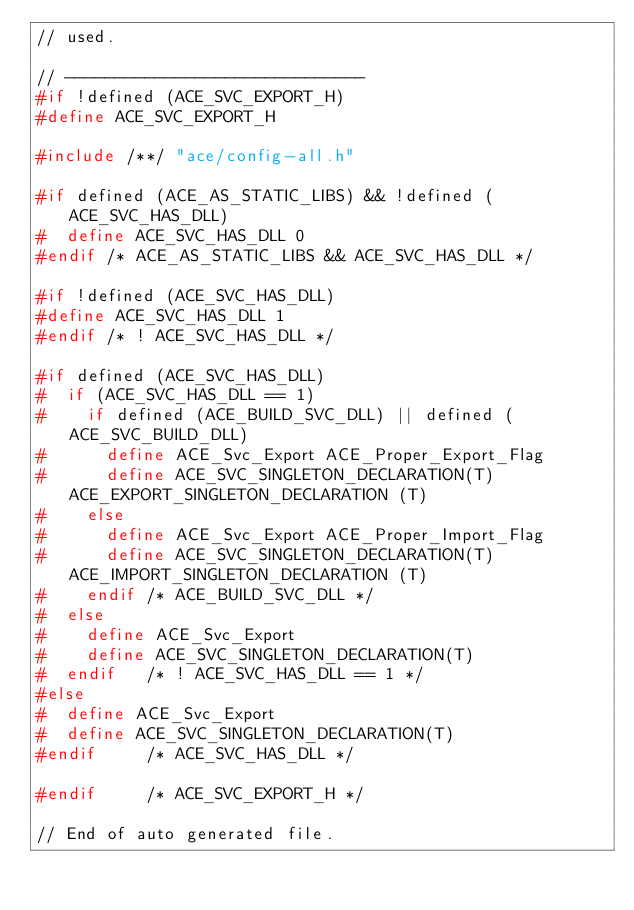Convert code to text. <code><loc_0><loc_0><loc_500><loc_500><_C_>// used.

// ------------------------------
#if !defined (ACE_SVC_EXPORT_H)
#define ACE_SVC_EXPORT_H

#include /**/ "ace/config-all.h"

#if defined (ACE_AS_STATIC_LIBS) && !defined (ACE_SVC_HAS_DLL)
#  define ACE_SVC_HAS_DLL 0
#endif /* ACE_AS_STATIC_LIBS && ACE_SVC_HAS_DLL */

#if !defined (ACE_SVC_HAS_DLL)
#define ACE_SVC_HAS_DLL 1
#endif /* ! ACE_SVC_HAS_DLL */

#if defined (ACE_SVC_HAS_DLL)
#  if (ACE_SVC_HAS_DLL == 1)
#    if defined (ACE_BUILD_SVC_DLL) || defined (ACE_SVC_BUILD_DLL)
#      define ACE_Svc_Export ACE_Proper_Export_Flag
#      define ACE_SVC_SINGLETON_DECLARATION(T) ACE_EXPORT_SINGLETON_DECLARATION (T)
#    else
#      define ACE_Svc_Export ACE_Proper_Import_Flag
#      define ACE_SVC_SINGLETON_DECLARATION(T) ACE_IMPORT_SINGLETON_DECLARATION (T)
#    endif /* ACE_BUILD_SVC_DLL */
#  else
#    define ACE_Svc_Export
#    define ACE_SVC_SINGLETON_DECLARATION(T)
#  endif   /* ! ACE_SVC_HAS_DLL == 1 */
#else
#  define ACE_Svc_Export
#  define ACE_SVC_SINGLETON_DECLARATION(T)
#endif     /* ACE_SVC_HAS_DLL */

#endif     /* ACE_SVC_EXPORT_H */

// End of auto generated file.
</code> 